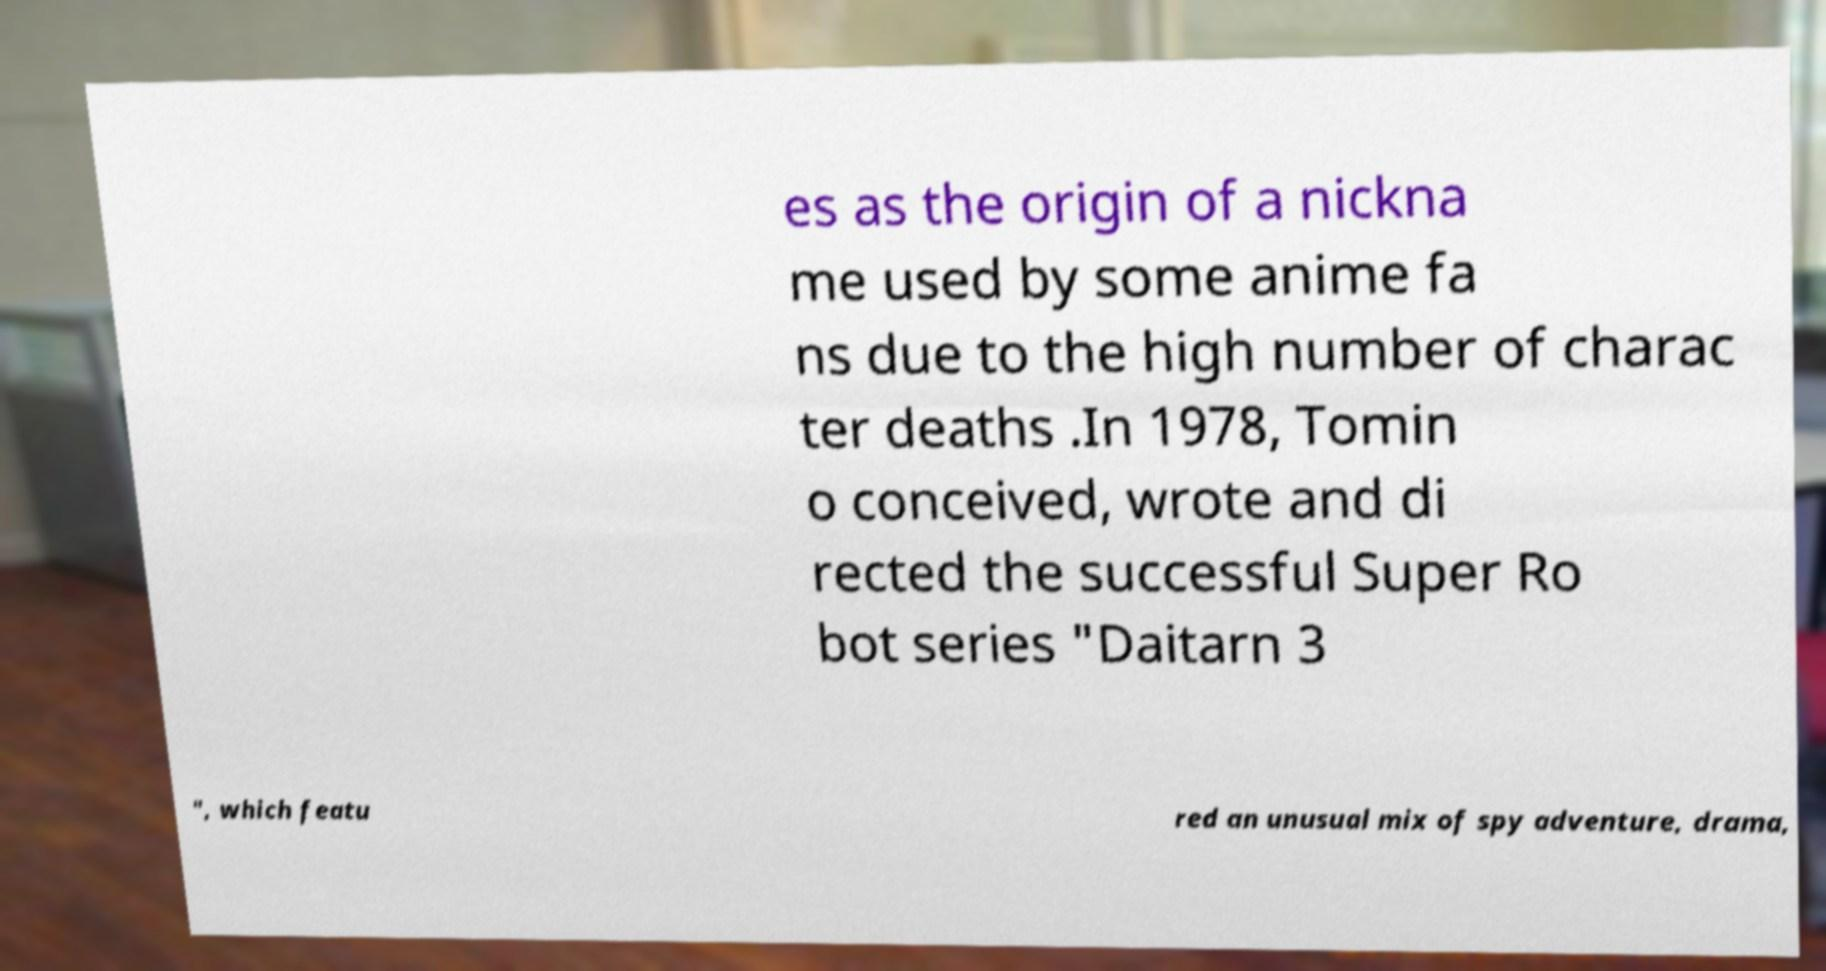Could you extract and type out the text from this image? es as the origin of a nickna me used by some anime fa ns due to the high number of charac ter deaths .In 1978, Tomin o conceived, wrote and di rected the successful Super Ro bot series "Daitarn 3 ", which featu red an unusual mix of spy adventure, drama, 